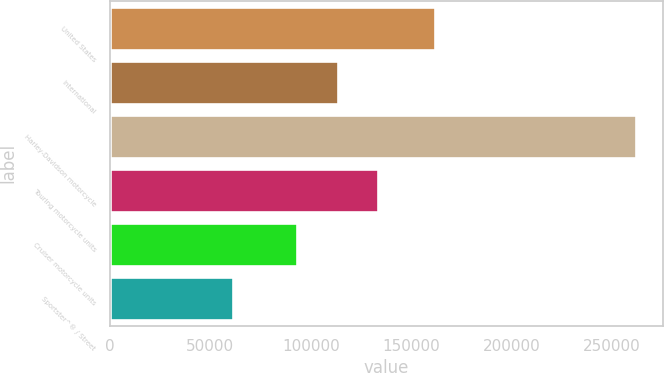<chart> <loc_0><loc_0><loc_500><loc_500><bar_chart><fcel>United States<fcel>International<fcel>Harley-Davidson motorcycle<fcel>Touring motorcycle units<fcel>Cruiser motorcycle units<fcel>Sportster^® / Street<nl><fcel>161839<fcel>113505<fcel>262221<fcel>133588<fcel>93422<fcel>61389<nl></chart> 